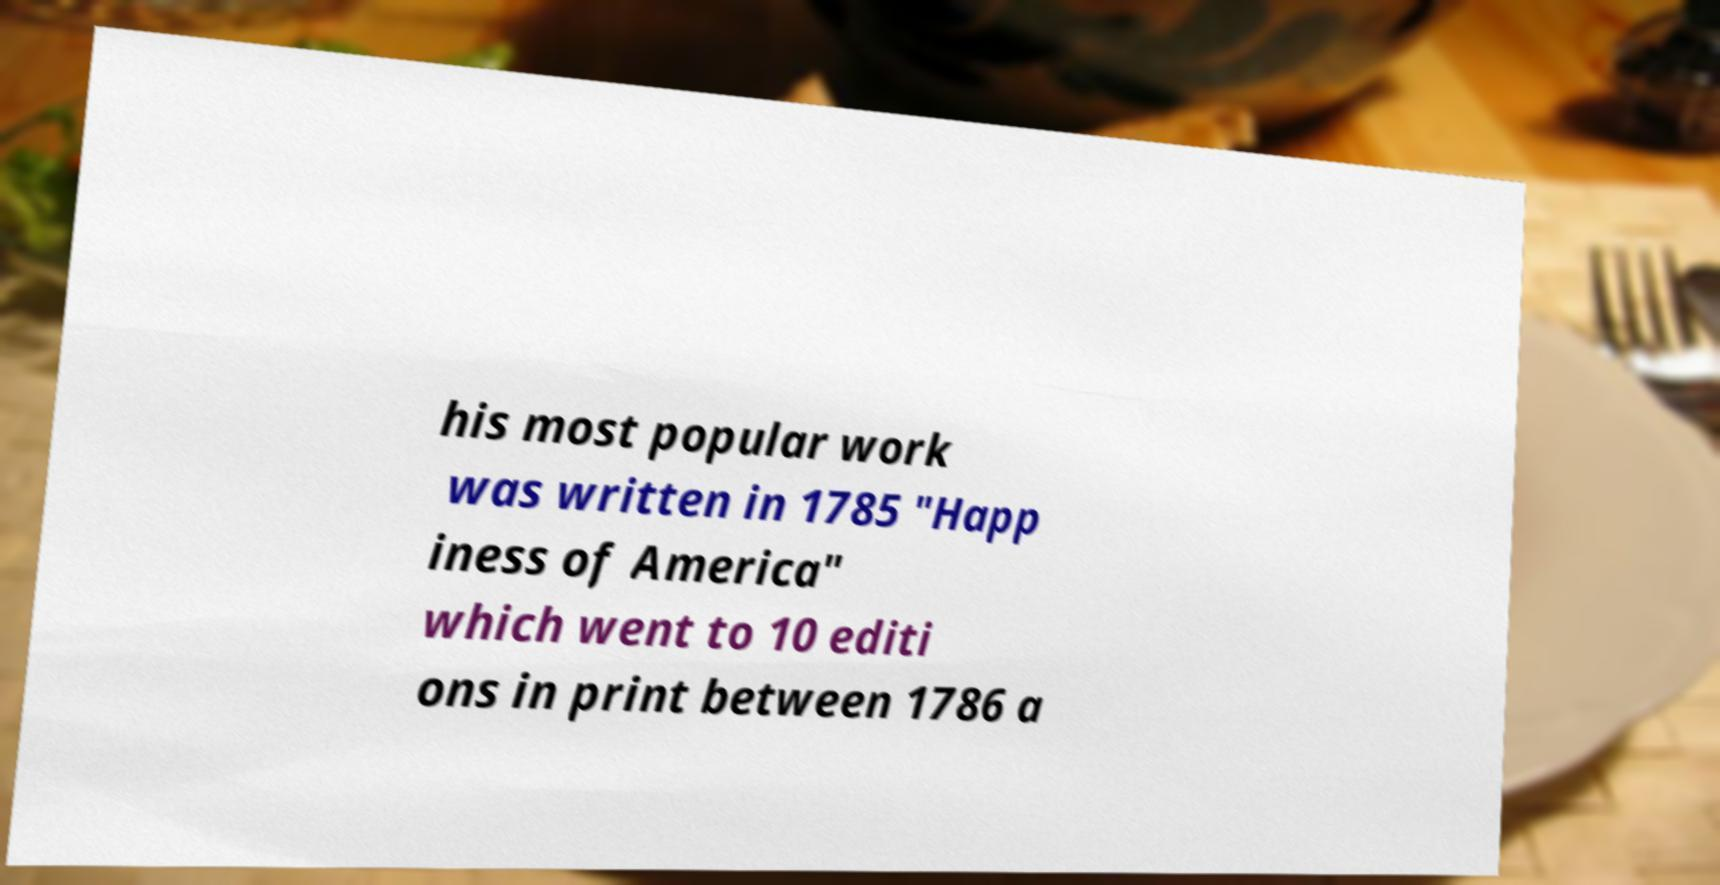For documentation purposes, I need the text within this image transcribed. Could you provide that? his most popular work was written in 1785 "Happ iness of America" which went to 10 editi ons in print between 1786 a 